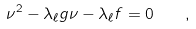Convert formula to latex. <formula><loc_0><loc_0><loc_500><loc_500>\nu ^ { 2 } - \lambda _ { \ell } g \nu - \lambda _ { \ell } f = 0 \quad ,</formula> 